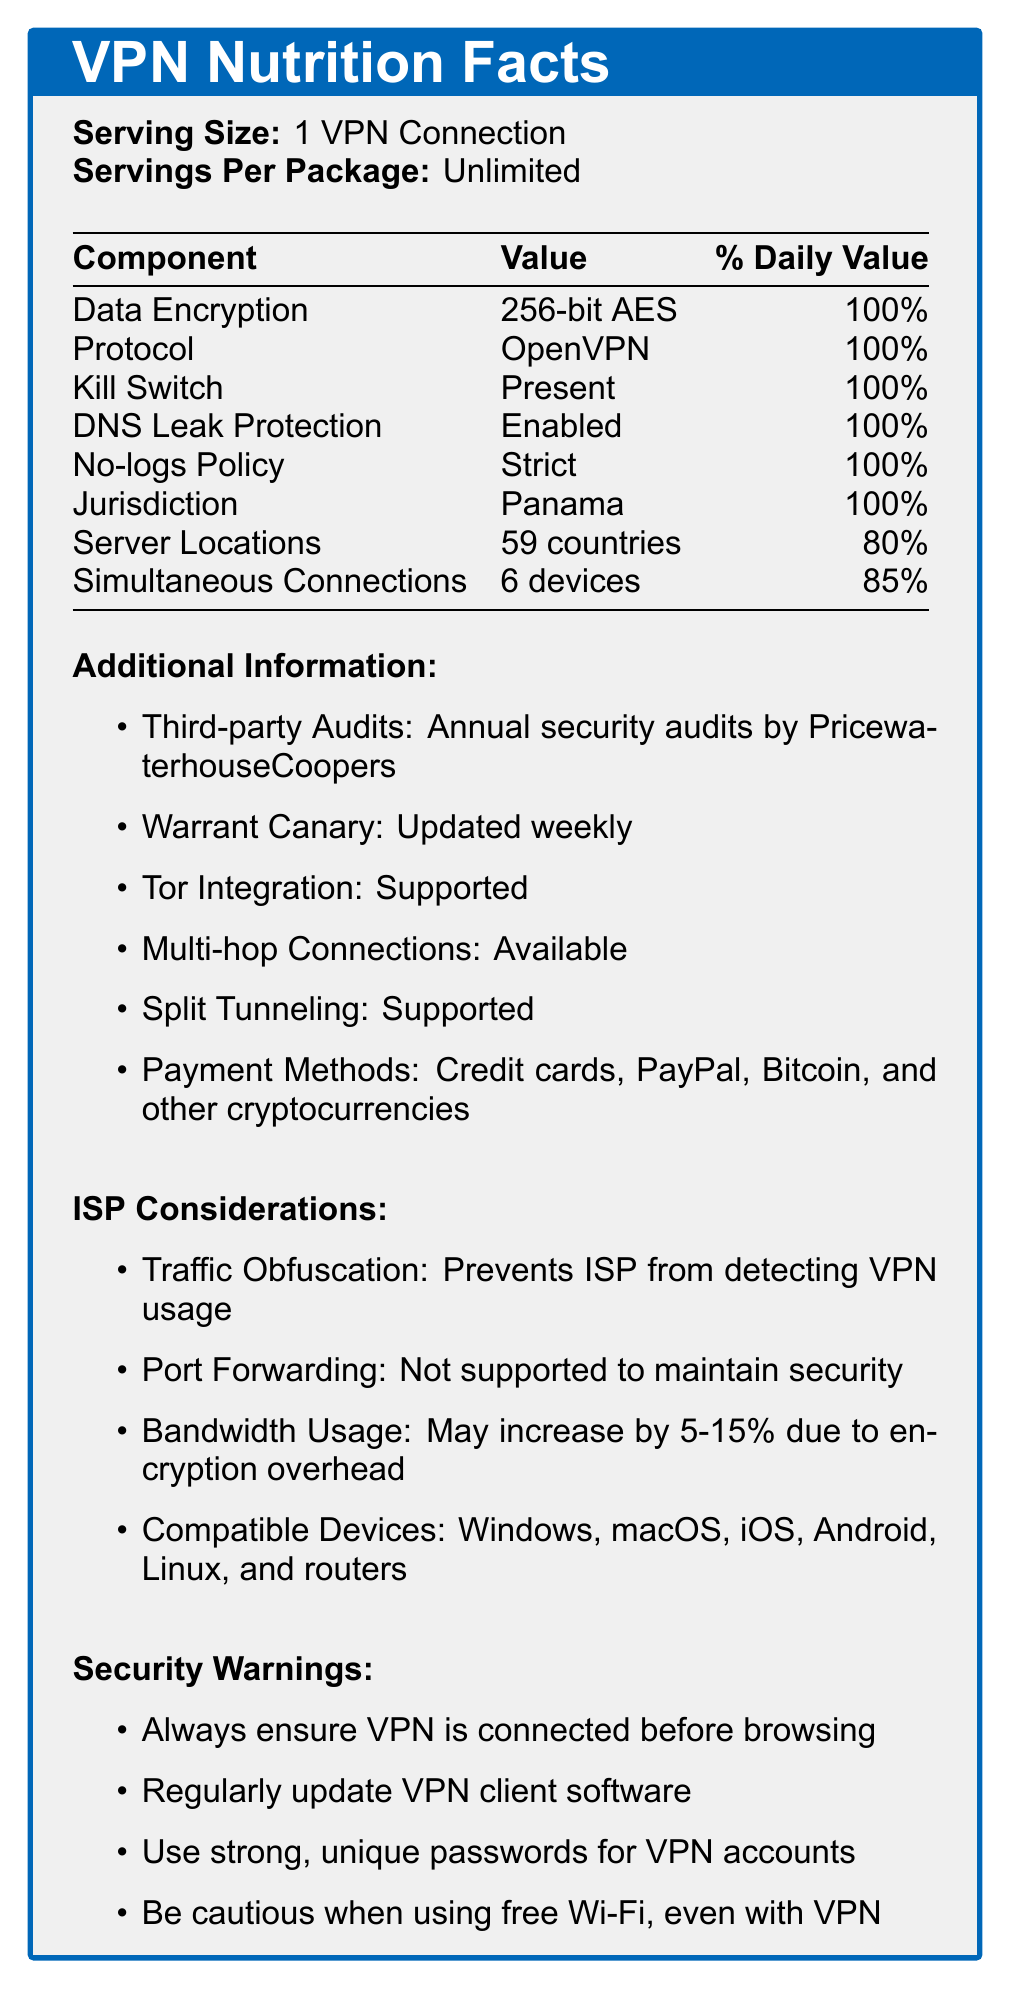what is the serving size for the VPN service? The serving size is explicitly mentioned at the beginning of the document: "Serving Size: 1 VPN Connection".
Answer: 1 VPN Connection which protocol is used by the VPN service? The document lists the protocol as OpenVPN under the Nutrition Facts section with a 100% daily value.
Answer: OpenVPN is DNS Leak Protection enabled? The document states "DNS Leak Protection: Enabled" under the Nutrition Facts section.
Answer: Yes how many devices can connect simultaneously to the VPN? The document lists "Simultaneous Connections: 6 devices" under the Nutrition Facts section with an 85% daily value.
Answer: 6 devices where is the VPN service's jurisdiction? The document specifies that the jurisdiction is Panama under the Nutrition Facts section, with a 100% daily value.
Answer: Panama what encryption standard is used by the VPN? Under the Nutrition Facts section, the document states "Data Encryption: 256-bit AES" with a 100% daily value.
Answer: 256-bit AES which of the following payment methods is not accepted?
A. Credit Card
B. PayPal
C. Bitcoin
D. Bank Transfer The document lists acceptable payment methods as "Credit cards, PayPal, Bitcoin, and other cryptocurrencies."
Answer: D. Bank Transfer how often are third-party audits conducted? The document states "Annual security audits by PricewaterhouseCoopers" under Additional Information.
Answer: Annually which aspect helps prevent the ISP from detecting VPN usage? 
I. Traffic Obfuscation
II. Kill Switch
III. Port Forwarding The document mentions under ISP Considerations that "Traffic Obfuscation: Prevents ISP from detecting VPN usage."
Answer: I. Traffic Obfuscation is port forwarding supported by the VPN service? The document notes under ISP Considerations that "Port Forwarding: Not supported to maintain security."
Answer: No does the VPN service support multi-hop connections? Under Additional Information, the document states that "Multi-hop Connections: Available"
Answer: Yes what kind of support is mentioned for Tor integration? 
I. Supported
II. Not Supported
III. Partially Supported The document states "Tor Integration: Supported" under Additional Information.
Answer: I. Supported summarize the main idea of the document. The document is designed to give an overview of the VPN service's security and privacy features, ensuring users understand its capabilities and limitations.
Answer: The document provides detailed information about the features and security aspects of a VPN service, presented in a format similar to a Nutrition Facts label. Key metrics include data encryption, protocol, kill switch, DNS leak protection, no-logs policy, jurisdiction, server locations, and simultaneous connections. Additional information includes third-party audits, warrant canary details, Tor and multi-hop support, split tunneling, and payment methods. ISP considerations and various security warnings are also highlighted. what additional measures are advised to ensure security when using the VPN service? The document lists these security warnings under the Security Warnings section.
Answer: Always ensure VPN is connected before browsing, Regularly update VPN client software, Use strong, unique passwords for VPN accounts, Be cautious when using free Wi-Fi, even with VPN what is the impact on bandwidth usage due to the VPN service? As stated in ISP Considerations, bandwidth usage may increase by 5-15% due to encryption overhead.
Answer: May increase by 5-15% due to encryption overhead how often is the warrant canary updated? The document mentions "Warrant Canary: Updated weekly" under Additional Information.
Answer: Weekly which jurisdictions besides Panama are involved in this VPN service? The document only mentions "Jurisdiction: Panama" without specifying any other jurisdictions.
Answer: Cannot be determined which audit firm conducts the VPN's annual security audits? The document lists "Third-party Audits: Annual security audits by PricewaterhouseCoopers" under Additional Information.
Answer: PricewaterhouseCoopers what is the purpose of traffic obfuscation? The document states this purpose under ISP Considerations: "Traffic Obfuscation: Prevents ISP from detecting VPN usage."
Answer: Prevents ISP from detecting VPN usage does the VPN service support split tunneling? The document states "Split Tunneling: Supported" under Additional Information.
Answer: Yes what information is provided about server locations? The document lists "Server Locations: 59 countries" under the Nutrition Facts section with an 80% daily value.
Answer: 59 countries 